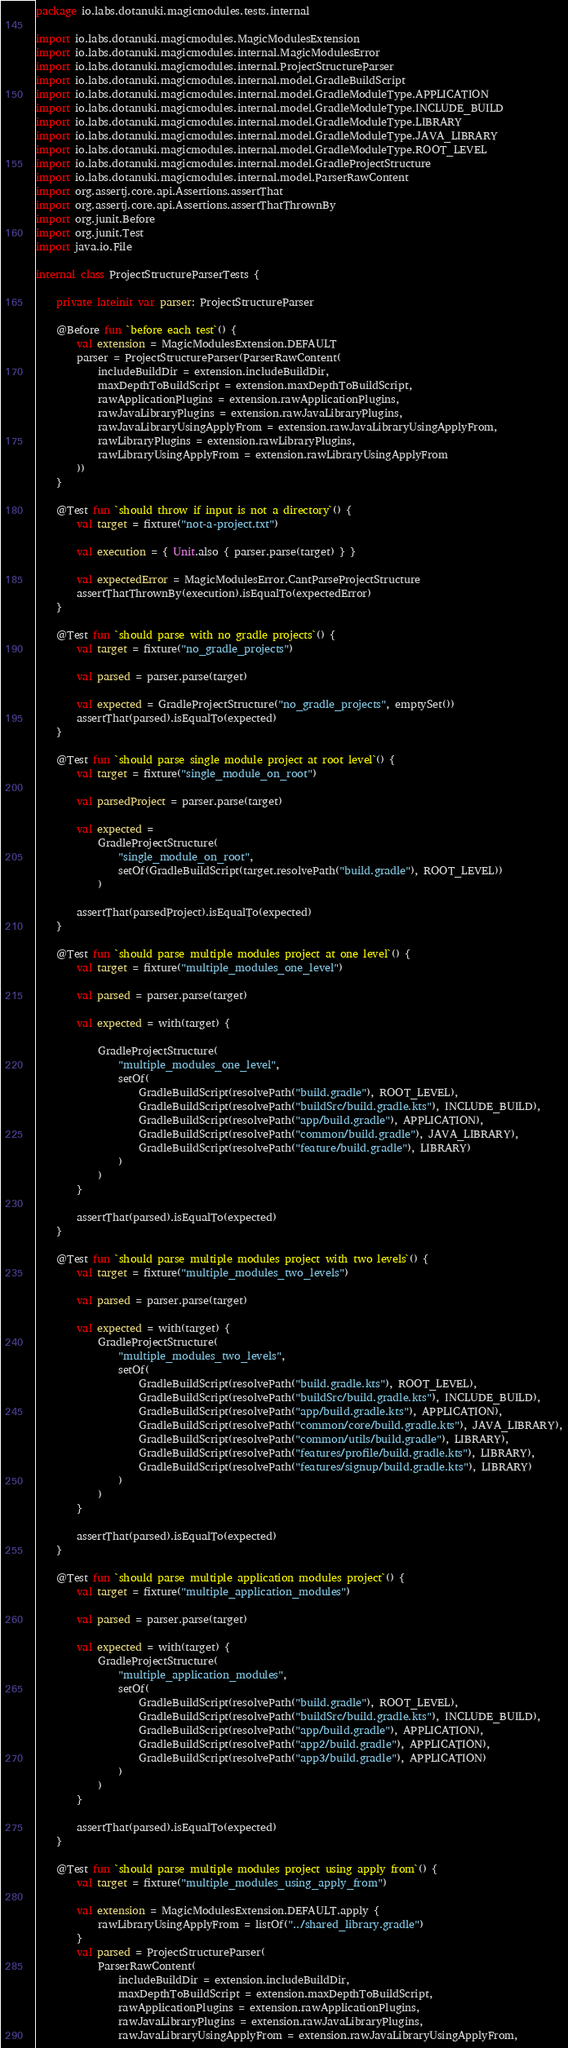<code> <loc_0><loc_0><loc_500><loc_500><_Kotlin_>package io.labs.dotanuki.magicmodules.tests.internal

import io.labs.dotanuki.magicmodules.MagicModulesExtension
import io.labs.dotanuki.magicmodules.internal.MagicModulesError
import io.labs.dotanuki.magicmodules.internal.ProjectStructureParser
import io.labs.dotanuki.magicmodules.internal.model.GradleBuildScript
import io.labs.dotanuki.magicmodules.internal.model.GradleModuleType.APPLICATION
import io.labs.dotanuki.magicmodules.internal.model.GradleModuleType.INCLUDE_BUILD
import io.labs.dotanuki.magicmodules.internal.model.GradleModuleType.LIBRARY
import io.labs.dotanuki.magicmodules.internal.model.GradleModuleType.JAVA_LIBRARY
import io.labs.dotanuki.magicmodules.internal.model.GradleModuleType.ROOT_LEVEL
import io.labs.dotanuki.magicmodules.internal.model.GradleProjectStructure
import io.labs.dotanuki.magicmodules.internal.model.ParserRawContent
import org.assertj.core.api.Assertions.assertThat
import org.assertj.core.api.Assertions.assertThatThrownBy
import org.junit.Before
import org.junit.Test
import java.io.File

internal class ProjectStructureParserTests {

    private lateinit var parser: ProjectStructureParser

    @Before fun `before each test`() {
        val extension = MagicModulesExtension.DEFAULT
        parser = ProjectStructureParser(ParserRawContent(
            includeBuildDir = extension.includeBuildDir,
            maxDepthToBuildScript = extension.maxDepthToBuildScript,
            rawApplicationPlugins = extension.rawApplicationPlugins,
            rawJavaLibraryPlugins = extension.rawJavaLibraryPlugins,
            rawJavaLibraryUsingApplyFrom = extension.rawJavaLibraryUsingApplyFrom,
            rawLibraryPlugins = extension.rawLibraryPlugins,
            rawLibraryUsingApplyFrom = extension.rawLibraryUsingApplyFrom
        ))
    }

    @Test fun `should throw if input is not a directory`() {
        val target = fixture("not-a-project.txt")

        val execution = { Unit.also { parser.parse(target) } }

        val expectedError = MagicModulesError.CantParseProjectStructure
        assertThatThrownBy(execution).isEqualTo(expectedError)
    }

    @Test fun `should parse with no gradle projects`() {
        val target = fixture("no_gradle_projects")

        val parsed = parser.parse(target)

        val expected = GradleProjectStructure("no_gradle_projects", emptySet())
        assertThat(parsed).isEqualTo(expected)
    }

    @Test fun `should parse single module project at root level`() {
        val target = fixture("single_module_on_root")

        val parsedProject = parser.parse(target)

        val expected =
            GradleProjectStructure(
                "single_module_on_root",
                setOf(GradleBuildScript(target.resolvePath("build.gradle"), ROOT_LEVEL))
            )

        assertThat(parsedProject).isEqualTo(expected)
    }

    @Test fun `should parse multiple modules project at one level`() {
        val target = fixture("multiple_modules_one_level")

        val parsed = parser.parse(target)

        val expected = with(target) {

            GradleProjectStructure(
                "multiple_modules_one_level",
                setOf(
                    GradleBuildScript(resolvePath("build.gradle"), ROOT_LEVEL),
                    GradleBuildScript(resolvePath("buildSrc/build.gradle.kts"), INCLUDE_BUILD),
                    GradleBuildScript(resolvePath("app/build.gradle"), APPLICATION),
                    GradleBuildScript(resolvePath("common/build.gradle"), JAVA_LIBRARY),
                    GradleBuildScript(resolvePath("feature/build.gradle"), LIBRARY)
                )
            )
        }

        assertThat(parsed).isEqualTo(expected)
    }

    @Test fun `should parse multiple modules project with two levels`() {
        val target = fixture("multiple_modules_two_levels")

        val parsed = parser.parse(target)

        val expected = with(target) {
            GradleProjectStructure(
                "multiple_modules_two_levels",
                setOf(
                    GradleBuildScript(resolvePath("build.gradle.kts"), ROOT_LEVEL),
                    GradleBuildScript(resolvePath("buildSrc/build.gradle.kts"), INCLUDE_BUILD),
                    GradleBuildScript(resolvePath("app/build.gradle.kts"), APPLICATION),
                    GradleBuildScript(resolvePath("common/core/build.gradle.kts"), JAVA_LIBRARY),
                    GradleBuildScript(resolvePath("common/utils/build.gradle"), LIBRARY),
                    GradleBuildScript(resolvePath("features/profile/build.gradle.kts"), LIBRARY),
                    GradleBuildScript(resolvePath("features/signup/build.gradle.kts"), LIBRARY)
                )
            )
        }

        assertThat(parsed).isEqualTo(expected)
    }

    @Test fun `should parse multiple application modules project`() {
        val target = fixture("multiple_application_modules")

        val parsed = parser.parse(target)

        val expected = with(target) {
            GradleProjectStructure(
                "multiple_application_modules",
                setOf(
                    GradleBuildScript(resolvePath("build.gradle"), ROOT_LEVEL),
                    GradleBuildScript(resolvePath("buildSrc/build.gradle.kts"), INCLUDE_BUILD),
                    GradleBuildScript(resolvePath("app/build.gradle"), APPLICATION),
                    GradleBuildScript(resolvePath("app2/build.gradle"), APPLICATION),
                    GradleBuildScript(resolvePath("app3/build.gradle"), APPLICATION)
                )
            )
        }

        assertThat(parsed).isEqualTo(expected)
    }

    @Test fun `should parse multiple modules project using apply from`() {
        val target = fixture("multiple_modules_using_apply_from")

        val extension = MagicModulesExtension.DEFAULT.apply {
            rawLibraryUsingApplyFrom = listOf("../shared_library.gradle")
        }
        val parsed = ProjectStructureParser(
            ParserRawContent(
                includeBuildDir = extension.includeBuildDir,
                maxDepthToBuildScript = extension.maxDepthToBuildScript,
                rawApplicationPlugins = extension.rawApplicationPlugins,
                rawJavaLibraryPlugins = extension.rawJavaLibraryPlugins,
                rawJavaLibraryUsingApplyFrom = extension.rawJavaLibraryUsingApplyFrom,</code> 